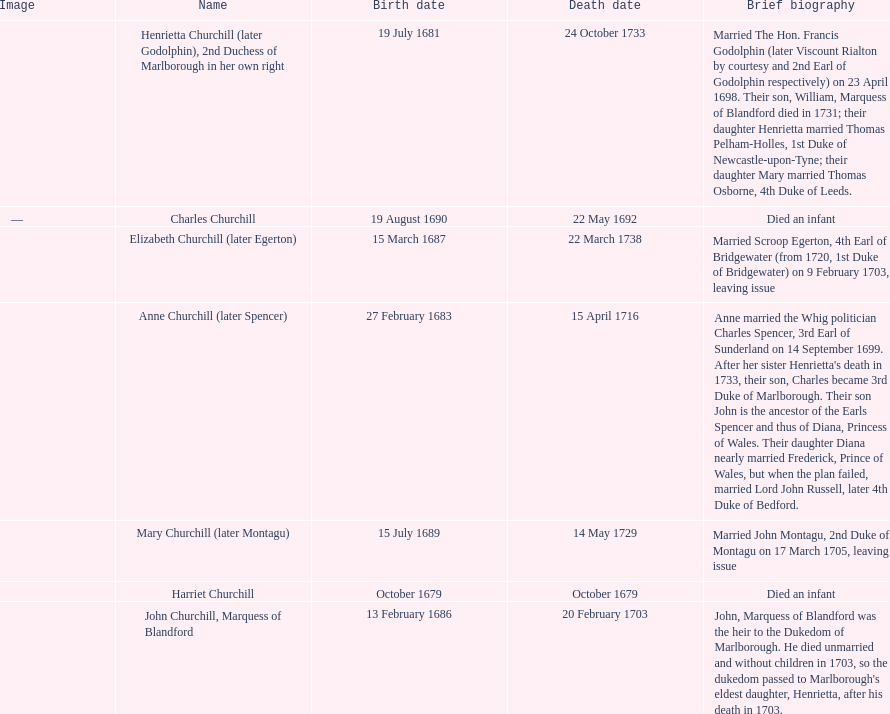How long did anne churchill/spencer live? 33. 